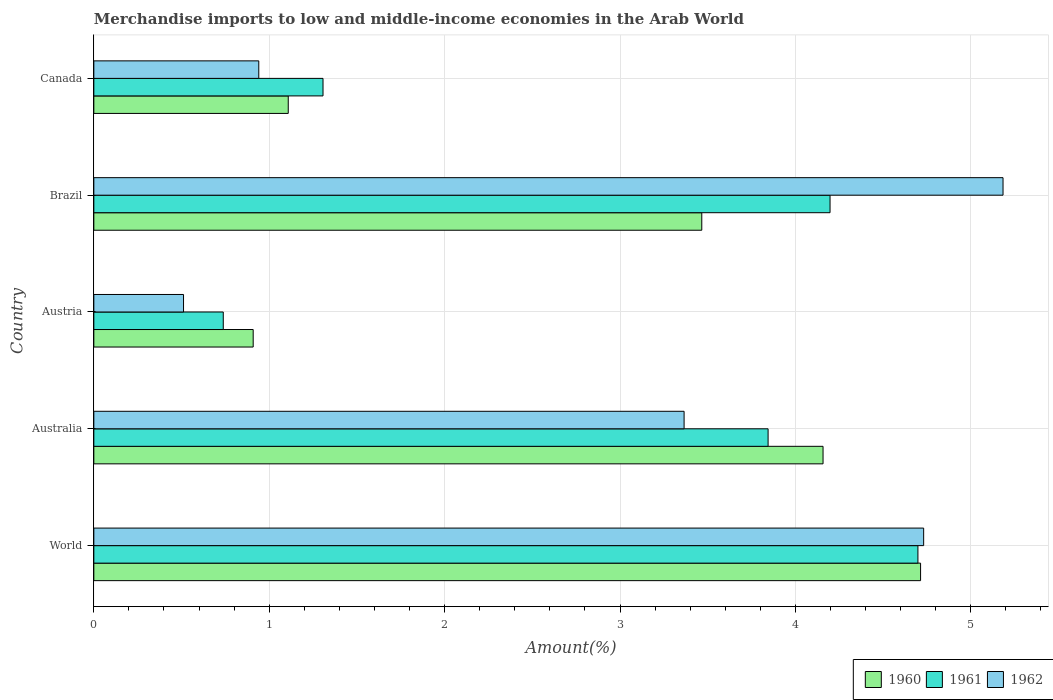How many groups of bars are there?
Keep it short and to the point. 5. Are the number of bars per tick equal to the number of legend labels?
Your response must be concise. Yes. How many bars are there on the 2nd tick from the top?
Offer a terse response. 3. What is the label of the 2nd group of bars from the top?
Your answer should be compact. Brazil. In how many cases, is the number of bars for a given country not equal to the number of legend labels?
Your answer should be very brief. 0. What is the percentage of amount earned from merchandise imports in 1960 in Canada?
Offer a very short reply. 1.11. Across all countries, what is the maximum percentage of amount earned from merchandise imports in 1962?
Ensure brevity in your answer.  5.18. Across all countries, what is the minimum percentage of amount earned from merchandise imports in 1960?
Make the answer very short. 0.91. In which country was the percentage of amount earned from merchandise imports in 1961 maximum?
Offer a terse response. World. What is the total percentage of amount earned from merchandise imports in 1961 in the graph?
Give a very brief answer. 14.78. What is the difference between the percentage of amount earned from merchandise imports in 1962 in Australia and that in Austria?
Offer a terse response. 2.85. What is the difference between the percentage of amount earned from merchandise imports in 1961 in Canada and the percentage of amount earned from merchandise imports in 1960 in Australia?
Make the answer very short. -2.85. What is the average percentage of amount earned from merchandise imports in 1961 per country?
Your response must be concise. 2.96. What is the difference between the percentage of amount earned from merchandise imports in 1962 and percentage of amount earned from merchandise imports in 1961 in World?
Offer a terse response. 0.03. In how many countries, is the percentage of amount earned from merchandise imports in 1960 greater than 3.6 %?
Give a very brief answer. 2. What is the ratio of the percentage of amount earned from merchandise imports in 1961 in Canada to that in World?
Make the answer very short. 0.28. Is the percentage of amount earned from merchandise imports in 1962 in Austria less than that in Brazil?
Offer a terse response. Yes. What is the difference between the highest and the second highest percentage of amount earned from merchandise imports in 1960?
Provide a short and direct response. 0.56. What is the difference between the highest and the lowest percentage of amount earned from merchandise imports in 1962?
Give a very brief answer. 4.67. In how many countries, is the percentage of amount earned from merchandise imports in 1962 greater than the average percentage of amount earned from merchandise imports in 1962 taken over all countries?
Provide a succinct answer. 3. What does the 2nd bar from the top in World represents?
Provide a short and direct response. 1961. Is it the case that in every country, the sum of the percentage of amount earned from merchandise imports in 1962 and percentage of amount earned from merchandise imports in 1960 is greater than the percentage of amount earned from merchandise imports in 1961?
Your answer should be very brief. Yes. How many bars are there?
Offer a very short reply. 15. How many countries are there in the graph?
Ensure brevity in your answer.  5. What is the difference between two consecutive major ticks on the X-axis?
Give a very brief answer. 1. Are the values on the major ticks of X-axis written in scientific E-notation?
Keep it short and to the point. No. How are the legend labels stacked?
Offer a terse response. Horizontal. What is the title of the graph?
Provide a short and direct response. Merchandise imports to low and middle-income economies in the Arab World. Does "1991" appear as one of the legend labels in the graph?
Your answer should be very brief. No. What is the label or title of the X-axis?
Your answer should be very brief. Amount(%). What is the Amount(%) in 1960 in World?
Offer a terse response. 4.71. What is the Amount(%) of 1961 in World?
Offer a terse response. 4.7. What is the Amount(%) of 1962 in World?
Keep it short and to the point. 4.73. What is the Amount(%) in 1960 in Australia?
Give a very brief answer. 4.16. What is the Amount(%) of 1961 in Australia?
Give a very brief answer. 3.84. What is the Amount(%) in 1962 in Australia?
Provide a short and direct response. 3.37. What is the Amount(%) in 1960 in Austria?
Provide a short and direct response. 0.91. What is the Amount(%) in 1961 in Austria?
Make the answer very short. 0.74. What is the Amount(%) in 1962 in Austria?
Your response must be concise. 0.51. What is the Amount(%) of 1960 in Brazil?
Your answer should be compact. 3.47. What is the Amount(%) in 1961 in Brazil?
Provide a short and direct response. 4.2. What is the Amount(%) of 1962 in Brazil?
Your response must be concise. 5.18. What is the Amount(%) of 1960 in Canada?
Your answer should be compact. 1.11. What is the Amount(%) of 1961 in Canada?
Your answer should be very brief. 1.31. What is the Amount(%) of 1962 in Canada?
Offer a very short reply. 0.94. Across all countries, what is the maximum Amount(%) of 1960?
Keep it short and to the point. 4.71. Across all countries, what is the maximum Amount(%) of 1961?
Make the answer very short. 4.7. Across all countries, what is the maximum Amount(%) in 1962?
Give a very brief answer. 5.18. Across all countries, what is the minimum Amount(%) in 1960?
Give a very brief answer. 0.91. Across all countries, what is the minimum Amount(%) in 1961?
Offer a terse response. 0.74. Across all countries, what is the minimum Amount(%) of 1962?
Ensure brevity in your answer.  0.51. What is the total Amount(%) of 1960 in the graph?
Provide a succinct answer. 14.35. What is the total Amount(%) in 1961 in the graph?
Provide a short and direct response. 14.78. What is the total Amount(%) of 1962 in the graph?
Your answer should be compact. 14.73. What is the difference between the Amount(%) of 1960 in World and that in Australia?
Your answer should be compact. 0.56. What is the difference between the Amount(%) of 1961 in World and that in Australia?
Give a very brief answer. 0.85. What is the difference between the Amount(%) of 1962 in World and that in Australia?
Your answer should be very brief. 1.37. What is the difference between the Amount(%) in 1960 in World and that in Austria?
Provide a short and direct response. 3.81. What is the difference between the Amount(%) in 1961 in World and that in Austria?
Ensure brevity in your answer.  3.96. What is the difference between the Amount(%) in 1962 in World and that in Austria?
Your response must be concise. 4.22. What is the difference between the Amount(%) in 1960 in World and that in Brazil?
Your response must be concise. 1.25. What is the difference between the Amount(%) in 1961 in World and that in Brazil?
Make the answer very short. 0.5. What is the difference between the Amount(%) in 1962 in World and that in Brazil?
Your answer should be very brief. -0.45. What is the difference between the Amount(%) of 1960 in World and that in Canada?
Ensure brevity in your answer.  3.61. What is the difference between the Amount(%) of 1961 in World and that in Canada?
Give a very brief answer. 3.39. What is the difference between the Amount(%) of 1962 in World and that in Canada?
Give a very brief answer. 3.79. What is the difference between the Amount(%) in 1960 in Australia and that in Austria?
Provide a succinct answer. 3.25. What is the difference between the Amount(%) of 1961 in Australia and that in Austria?
Keep it short and to the point. 3.11. What is the difference between the Amount(%) in 1962 in Australia and that in Austria?
Ensure brevity in your answer.  2.85. What is the difference between the Amount(%) in 1960 in Australia and that in Brazil?
Your answer should be compact. 0.69. What is the difference between the Amount(%) of 1961 in Australia and that in Brazil?
Ensure brevity in your answer.  -0.35. What is the difference between the Amount(%) of 1962 in Australia and that in Brazil?
Make the answer very short. -1.82. What is the difference between the Amount(%) of 1960 in Australia and that in Canada?
Provide a short and direct response. 3.05. What is the difference between the Amount(%) in 1961 in Australia and that in Canada?
Offer a very short reply. 2.54. What is the difference between the Amount(%) of 1962 in Australia and that in Canada?
Ensure brevity in your answer.  2.42. What is the difference between the Amount(%) of 1960 in Austria and that in Brazil?
Provide a short and direct response. -2.56. What is the difference between the Amount(%) of 1961 in Austria and that in Brazil?
Make the answer very short. -3.46. What is the difference between the Amount(%) in 1962 in Austria and that in Brazil?
Provide a succinct answer. -4.67. What is the difference between the Amount(%) of 1961 in Austria and that in Canada?
Give a very brief answer. -0.57. What is the difference between the Amount(%) in 1962 in Austria and that in Canada?
Give a very brief answer. -0.43. What is the difference between the Amount(%) of 1960 in Brazil and that in Canada?
Make the answer very short. 2.36. What is the difference between the Amount(%) in 1961 in Brazil and that in Canada?
Your response must be concise. 2.89. What is the difference between the Amount(%) in 1962 in Brazil and that in Canada?
Your response must be concise. 4.24. What is the difference between the Amount(%) in 1960 in World and the Amount(%) in 1961 in Australia?
Your answer should be compact. 0.87. What is the difference between the Amount(%) of 1960 in World and the Amount(%) of 1962 in Australia?
Ensure brevity in your answer.  1.35. What is the difference between the Amount(%) in 1961 in World and the Amount(%) in 1962 in Australia?
Offer a terse response. 1.33. What is the difference between the Amount(%) in 1960 in World and the Amount(%) in 1961 in Austria?
Give a very brief answer. 3.98. What is the difference between the Amount(%) in 1960 in World and the Amount(%) in 1962 in Austria?
Provide a succinct answer. 4.2. What is the difference between the Amount(%) in 1961 in World and the Amount(%) in 1962 in Austria?
Make the answer very short. 4.19. What is the difference between the Amount(%) of 1960 in World and the Amount(%) of 1961 in Brazil?
Your answer should be compact. 0.52. What is the difference between the Amount(%) in 1960 in World and the Amount(%) in 1962 in Brazil?
Offer a terse response. -0.47. What is the difference between the Amount(%) in 1961 in World and the Amount(%) in 1962 in Brazil?
Offer a very short reply. -0.49. What is the difference between the Amount(%) of 1960 in World and the Amount(%) of 1961 in Canada?
Provide a short and direct response. 3.41. What is the difference between the Amount(%) of 1960 in World and the Amount(%) of 1962 in Canada?
Offer a very short reply. 3.77. What is the difference between the Amount(%) in 1961 in World and the Amount(%) in 1962 in Canada?
Offer a very short reply. 3.76. What is the difference between the Amount(%) in 1960 in Australia and the Amount(%) in 1961 in Austria?
Make the answer very short. 3.42. What is the difference between the Amount(%) in 1960 in Australia and the Amount(%) in 1962 in Austria?
Keep it short and to the point. 3.65. What is the difference between the Amount(%) in 1961 in Australia and the Amount(%) in 1962 in Austria?
Your answer should be very brief. 3.33. What is the difference between the Amount(%) in 1960 in Australia and the Amount(%) in 1961 in Brazil?
Your response must be concise. -0.04. What is the difference between the Amount(%) in 1960 in Australia and the Amount(%) in 1962 in Brazil?
Provide a succinct answer. -1.03. What is the difference between the Amount(%) in 1961 in Australia and the Amount(%) in 1962 in Brazil?
Provide a short and direct response. -1.34. What is the difference between the Amount(%) in 1960 in Australia and the Amount(%) in 1961 in Canada?
Make the answer very short. 2.85. What is the difference between the Amount(%) of 1960 in Australia and the Amount(%) of 1962 in Canada?
Make the answer very short. 3.22. What is the difference between the Amount(%) of 1961 in Australia and the Amount(%) of 1962 in Canada?
Your answer should be very brief. 2.9. What is the difference between the Amount(%) in 1960 in Austria and the Amount(%) in 1961 in Brazil?
Keep it short and to the point. -3.29. What is the difference between the Amount(%) of 1960 in Austria and the Amount(%) of 1962 in Brazil?
Offer a very short reply. -4.28. What is the difference between the Amount(%) of 1961 in Austria and the Amount(%) of 1962 in Brazil?
Make the answer very short. -4.45. What is the difference between the Amount(%) of 1960 in Austria and the Amount(%) of 1961 in Canada?
Keep it short and to the point. -0.4. What is the difference between the Amount(%) in 1960 in Austria and the Amount(%) in 1962 in Canada?
Ensure brevity in your answer.  -0.03. What is the difference between the Amount(%) of 1961 in Austria and the Amount(%) of 1962 in Canada?
Offer a terse response. -0.2. What is the difference between the Amount(%) of 1960 in Brazil and the Amount(%) of 1961 in Canada?
Your response must be concise. 2.16. What is the difference between the Amount(%) of 1960 in Brazil and the Amount(%) of 1962 in Canada?
Provide a succinct answer. 2.53. What is the difference between the Amount(%) of 1961 in Brazil and the Amount(%) of 1962 in Canada?
Offer a terse response. 3.26. What is the average Amount(%) of 1960 per country?
Keep it short and to the point. 2.87. What is the average Amount(%) in 1961 per country?
Offer a very short reply. 2.96. What is the average Amount(%) of 1962 per country?
Your answer should be very brief. 2.95. What is the difference between the Amount(%) of 1960 and Amount(%) of 1961 in World?
Offer a terse response. 0.02. What is the difference between the Amount(%) in 1960 and Amount(%) in 1962 in World?
Your answer should be very brief. -0.02. What is the difference between the Amount(%) in 1961 and Amount(%) in 1962 in World?
Give a very brief answer. -0.03. What is the difference between the Amount(%) in 1960 and Amount(%) in 1961 in Australia?
Give a very brief answer. 0.31. What is the difference between the Amount(%) of 1960 and Amount(%) of 1962 in Australia?
Ensure brevity in your answer.  0.79. What is the difference between the Amount(%) of 1961 and Amount(%) of 1962 in Australia?
Ensure brevity in your answer.  0.48. What is the difference between the Amount(%) of 1960 and Amount(%) of 1961 in Austria?
Provide a short and direct response. 0.17. What is the difference between the Amount(%) in 1960 and Amount(%) in 1962 in Austria?
Provide a succinct answer. 0.4. What is the difference between the Amount(%) of 1961 and Amount(%) of 1962 in Austria?
Provide a short and direct response. 0.23. What is the difference between the Amount(%) of 1960 and Amount(%) of 1961 in Brazil?
Keep it short and to the point. -0.73. What is the difference between the Amount(%) in 1960 and Amount(%) in 1962 in Brazil?
Your response must be concise. -1.72. What is the difference between the Amount(%) of 1961 and Amount(%) of 1962 in Brazil?
Offer a very short reply. -0.99. What is the difference between the Amount(%) of 1960 and Amount(%) of 1961 in Canada?
Ensure brevity in your answer.  -0.2. What is the difference between the Amount(%) in 1960 and Amount(%) in 1962 in Canada?
Keep it short and to the point. 0.17. What is the difference between the Amount(%) of 1961 and Amount(%) of 1962 in Canada?
Give a very brief answer. 0.37. What is the ratio of the Amount(%) of 1960 in World to that in Australia?
Give a very brief answer. 1.13. What is the ratio of the Amount(%) in 1961 in World to that in Australia?
Your response must be concise. 1.22. What is the ratio of the Amount(%) of 1962 in World to that in Australia?
Provide a succinct answer. 1.41. What is the ratio of the Amount(%) of 1960 in World to that in Austria?
Make the answer very short. 5.19. What is the ratio of the Amount(%) of 1961 in World to that in Austria?
Offer a very short reply. 6.37. What is the ratio of the Amount(%) in 1962 in World to that in Austria?
Give a very brief answer. 9.25. What is the ratio of the Amount(%) in 1960 in World to that in Brazil?
Your answer should be very brief. 1.36. What is the ratio of the Amount(%) in 1961 in World to that in Brazil?
Keep it short and to the point. 1.12. What is the ratio of the Amount(%) of 1962 in World to that in Brazil?
Provide a short and direct response. 0.91. What is the ratio of the Amount(%) of 1960 in World to that in Canada?
Your answer should be very brief. 4.25. What is the ratio of the Amount(%) of 1961 in World to that in Canada?
Offer a terse response. 3.6. What is the ratio of the Amount(%) in 1962 in World to that in Canada?
Offer a terse response. 5.03. What is the ratio of the Amount(%) in 1960 in Australia to that in Austria?
Ensure brevity in your answer.  4.58. What is the ratio of the Amount(%) in 1961 in Australia to that in Austria?
Provide a succinct answer. 5.21. What is the ratio of the Amount(%) of 1962 in Australia to that in Austria?
Give a very brief answer. 6.58. What is the ratio of the Amount(%) of 1960 in Australia to that in Brazil?
Provide a succinct answer. 1.2. What is the ratio of the Amount(%) in 1961 in Australia to that in Brazil?
Keep it short and to the point. 0.92. What is the ratio of the Amount(%) of 1962 in Australia to that in Brazil?
Offer a very short reply. 0.65. What is the ratio of the Amount(%) of 1960 in Australia to that in Canada?
Make the answer very short. 3.75. What is the ratio of the Amount(%) of 1961 in Australia to that in Canada?
Ensure brevity in your answer.  2.94. What is the ratio of the Amount(%) in 1962 in Australia to that in Canada?
Offer a terse response. 3.58. What is the ratio of the Amount(%) in 1960 in Austria to that in Brazil?
Make the answer very short. 0.26. What is the ratio of the Amount(%) in 1961 in Austria to that in Brazil?
Ensure brevity in your answer.  0.18. What is the ratio of the Amount(%) of 1962 in Austria to that in Brazil?
Provide a succinct answer. 0.1. What is the ratio of the Amount(%) in 1960 in Austria to that in Canada?
Give a very brief answer. 0.82. What is the ratio of the Amount(%) in 1961 in Austria to that in Canada?
Your response must be concise. 0.56. What is the ratio of the Amount(%) of 1962 in Austria to that in Canada?
Ensure brevity in your answer.  0.54. What is the ratio of the Amount(%) in 1960 in Brazil to that in Canada?
Offer a terse response. 3.13. What is the ratio of the Amount(%) of 1961 in Brazil to that in Canada?
Ensure brevity in your answer.  3.21. What is the ratio of the Amount(%) of 1962 in Brazil to that in Canada?
Your answer should be very brief. 5.51. What is the difference between the highest and the second highest Amount(%) in 1960?
Make the answer very short. 0.56. What is the difference between the highest and the second highest Amount(%) in 1961?
Your answer should be compact. 0.5. What is the difference between the highest and the second highest Amount(%) in 1962?
Offer a terse response. 0.45. What is the difference between the highest and the lowest Amount(%) of 1960?
Provide a short and direct response. 3.81. What is the difference between the highest and the lowest Amount(%) of 1961?
Keep it short and to the point. 3.96. What is the difference between the highest and the lowest Amount(%) of 1962?
Keep it short and to the point. 4.67. 